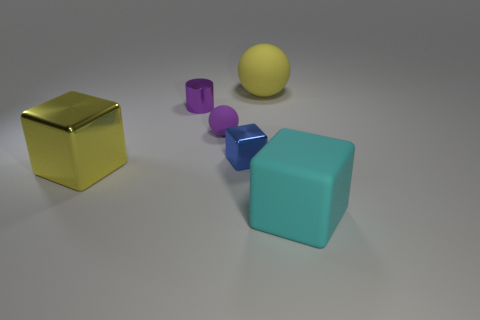Add 3 large yellow metallic things. How many objects exist? 9 Subtract all cylinders. How many objects are left? 5 Subtract 0 brown cubes. How many objects are left? 6 Subtract all blue things. Subtract all yellow cubes. How many objects are left? 4 Add 3 large balls. How many large balls are left? 4 Add 5 yellow rubber balls. How many yellow rubber balls exist? 6 